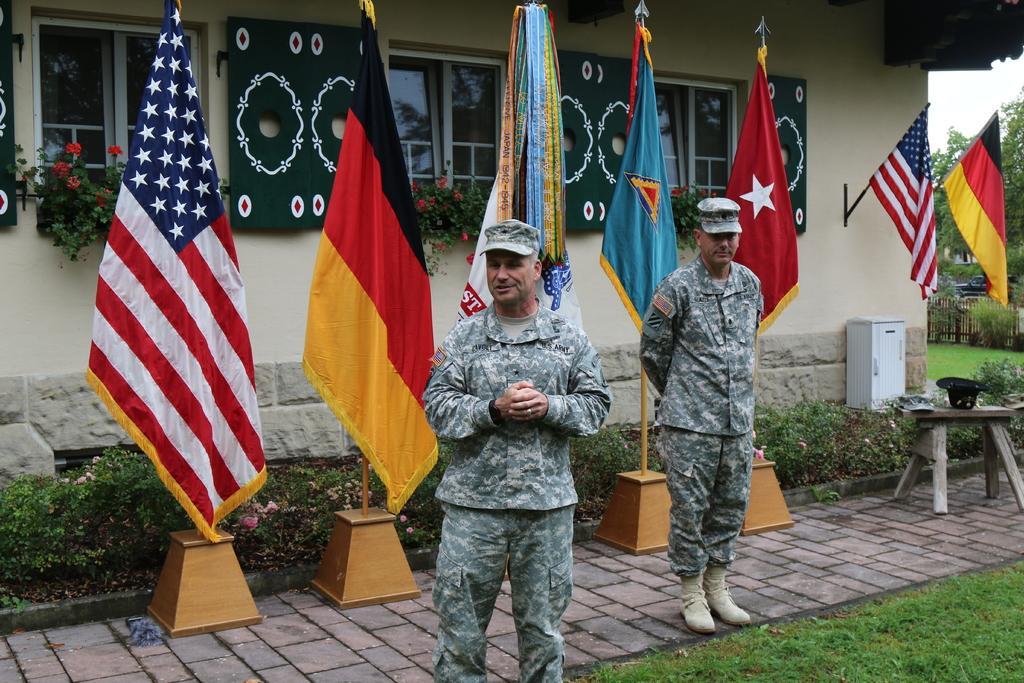Can you describe this image briefly? In the image there are two men standing with uniform. Behind them there are flags with poles. Behind the flags there are plants with flowers. And there is a wall with windows, plaits with flowers and flags are hanging onto the wall. On the right side of the image there are trees. 